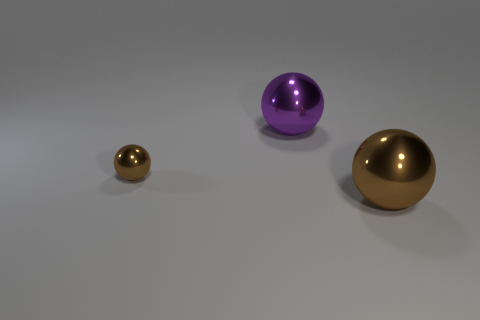What is the color of the tiny sphere?
Offer a very short reply. Brown. How many other things are there of the same color as the tiny metal object?
Ensure brevity in your answer.  1. Are there any big purple objects behind the tiny brown sphere?
Ensure brevity in your answer.  Yes. What color is the big ball that is left of the large thing that is in front of the large metal object that is behind the large brown ball?
Your answer should be very brief. Purple. How many metal spheres are both to the right of the small metallic sphere and in front of the large purple object?
Give a very brief answer. 1. What number of cubes are brown matte objects or purple things?
Ensure brevity in your answer.  0. Are there any big brown shiny objects?
Your response must be concise. Yes. How many other things are there of the same material as the tiny thing?
Your response must be concise. 2. There is a brown ball that is the same size as the purple thing; what is its material?
Ensure brevity in your answer.  Metal. Is the shape of the brown object that is left of the large brown shiny sphere the same as  the purple metallic thing?
Your answer should be very brief. Yes. 